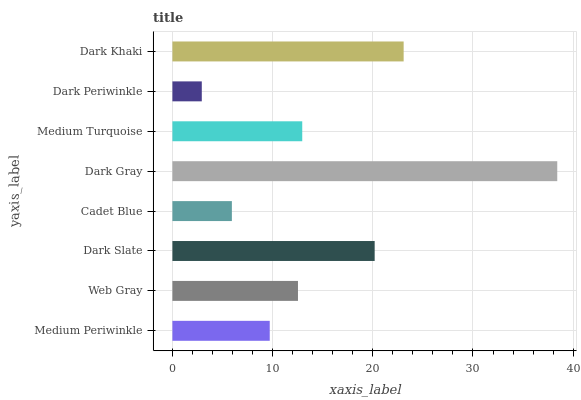Is Dark Periwinkle the minimum?
Answer yes or no. Yes. Is Dark Gray the maximum?
Answer yes or no. Yes. Is Web Gray the minimum?
Answer yes or no. No. Is Web Gray the maximum?
Answer yes or no. No. Is Web Gray greater than Medium Periwinkle?
Answer yes or no. Yes. Is Medium Periwinkle less than Web Gray?
Answer yes or no. Yes. Is Medium Periwinkle greater than Web Gray?
Answer yes or no. No. Is Web Gray less than Medium Periwinkle?
Answer yes or no. No. Is Medium Turquoise the high median?
Answer yes or no. Yes. Is Web Gray the low median?
Answer yes or no. Yes. Is Cadet Blue the high median?
Answer yes or no. No. Is Dark Periwinkle the low median?
Answer yes or no. No. 